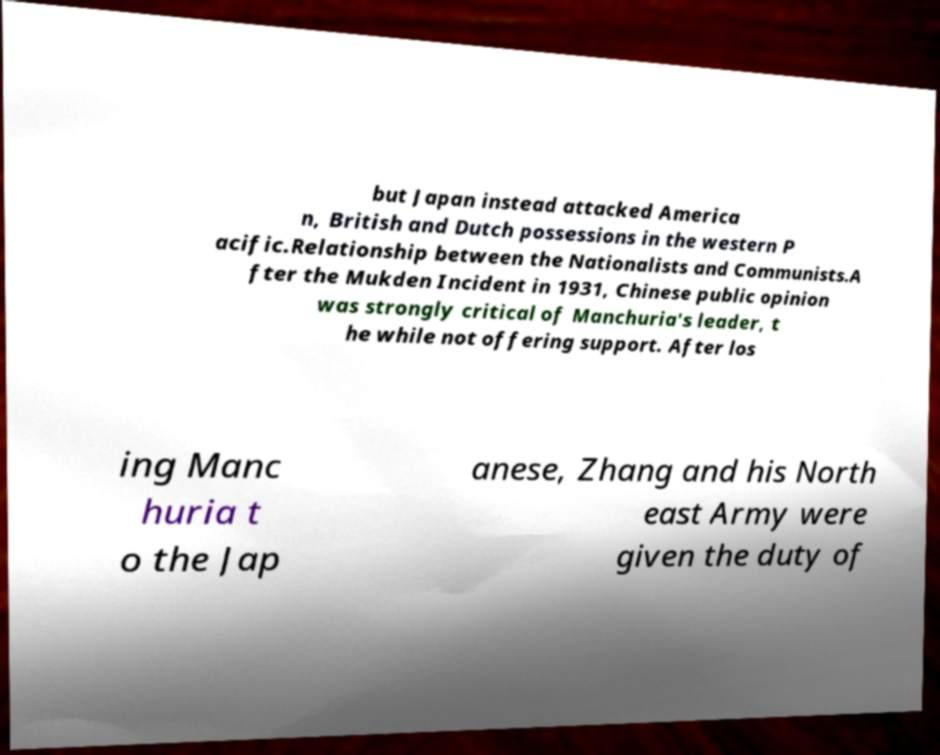I need the written content from this picture converted into text. Can you do that? but Japan instead attacked America n, British and Dutch possessions in the western P acific.Relationship between the Nationalists and Communists.A fter the Mukden Incident in 1931, Chinese public opinion was strongly critical of Manchuria's leader, t he while not offering support. After los ing Manc huria t o the Jap anese, Zhang and his North east Army were given the duty of 